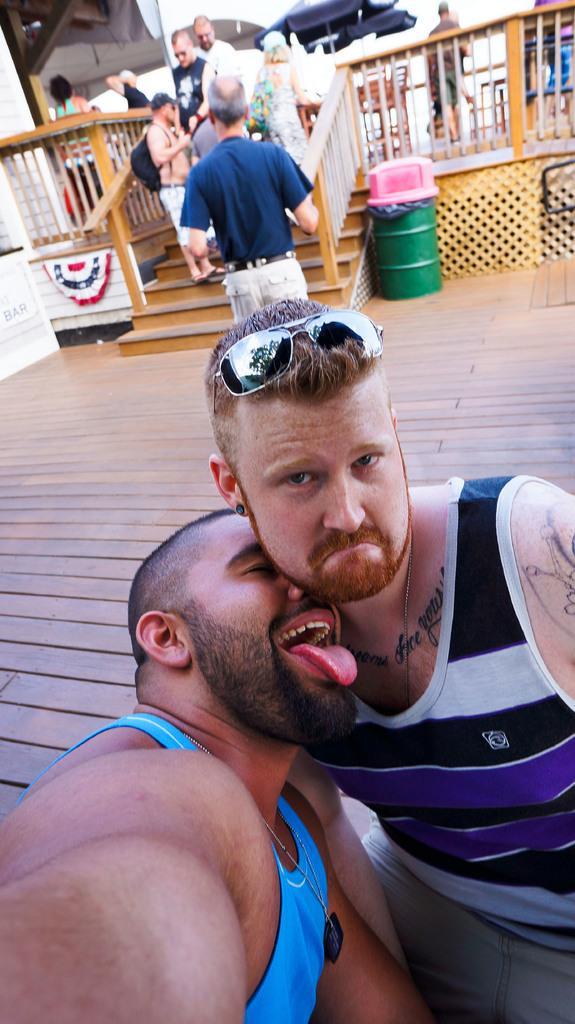How would you summarize this image in a sentence or two? This is a zoomed in picture. In the foreground we can see the two men seems to be sitting on the ground. In the center we can see the group of people and we can see the stairs, handrail, umbrella and some other objects in the background. 